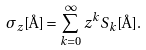<formula> <loc_0><loc_0><loc_500><loc_500>\sigma _ { z } [ \AA ] = \sum _ { k = 0 } ^ { \infty } z ^ { k } S _ { k } [ \AA ] .</formula> 